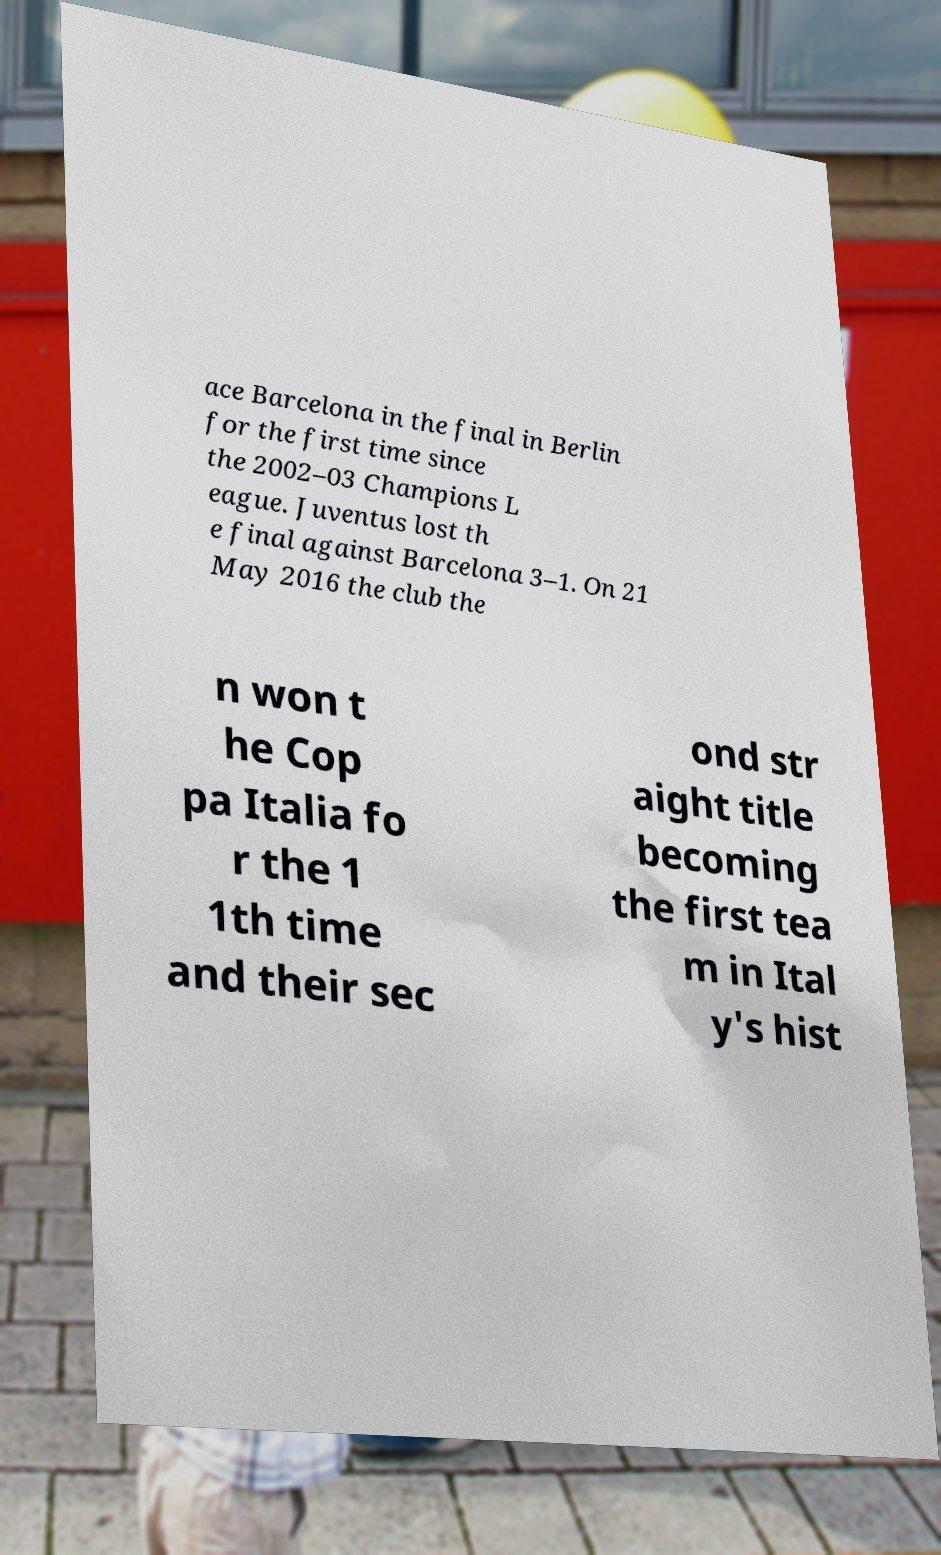Can you read and provide the text displayed in the image?This photo seems to have some interesting text. Can you extract and type it out for me? ace Barcelona in the final in Berlin for the first time since the 2002–03 Champions L eague. Juventus lost th e final against Barcelona 3–1. On 21 May 2016 the club the n won t he Cop pa Italia fo r the 1 1th time and their sec ond str aight title becoming the first tea m in Ital y's hist 